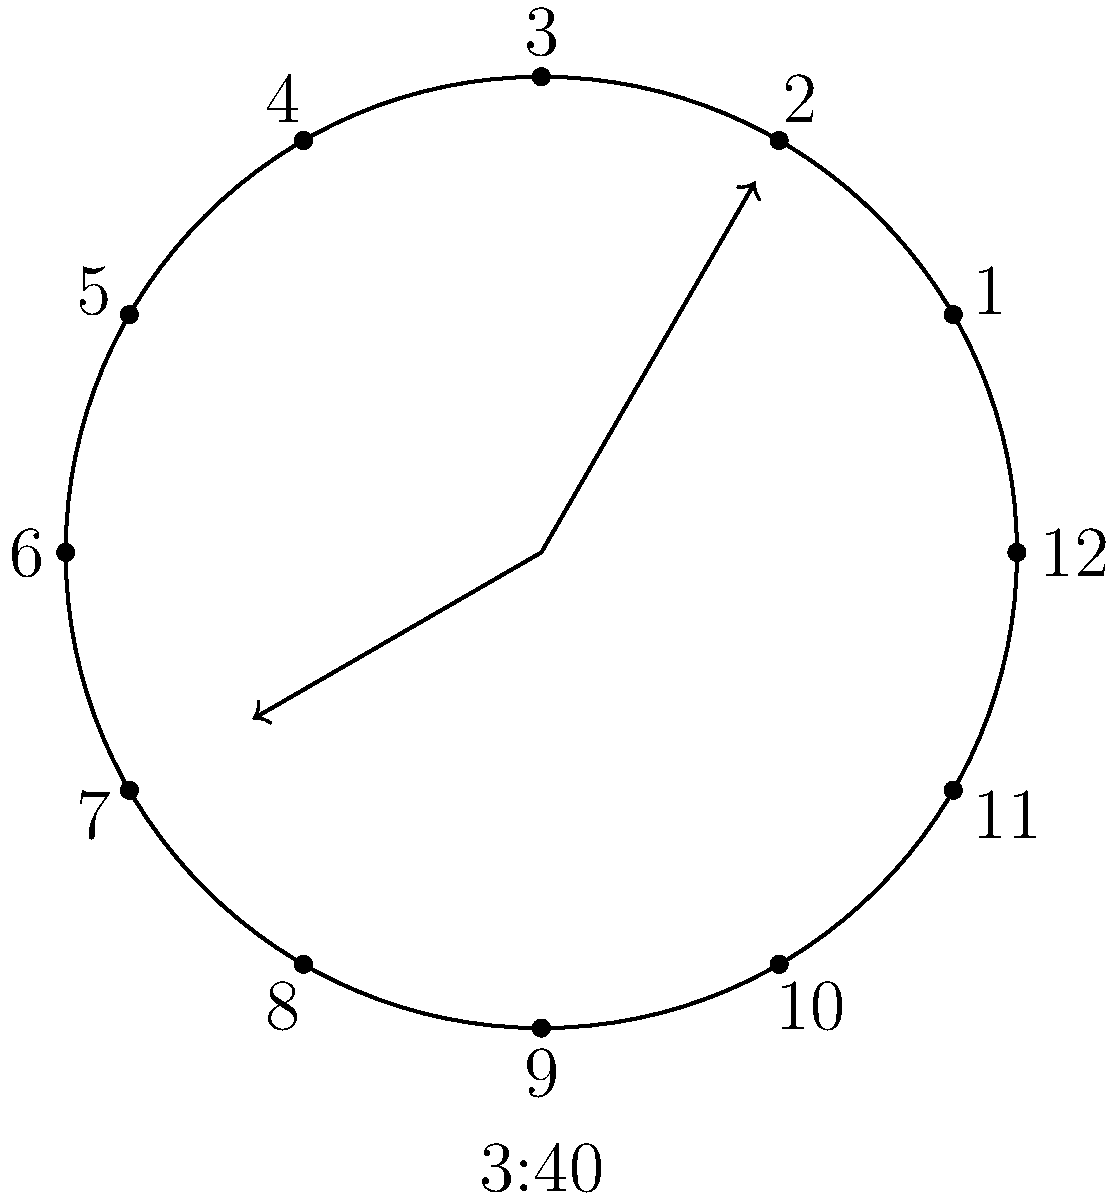As you're teaching your child to read an analog clock, you point out that at 3:40, the hour hand has moved slightly past 3. If we consider the angle formed between the hour and minute hands at this time, what is the measure of this angle to the nearest degree? Let's approach this step-by-step:

1) First, we need to calculate the angle of each hand:

   For the hour hand:
   - In 12 hours, it rotates 360°
   - In 1 hour, it rotates 360° ÷ 12 = 30°
   - In 40 minutes, it rotates an additional 40/60 * 30° = 20°
   - So at 3:40, the hour hand is at 3 * 30° + 20° = 110°

   For the minute hand:
   - In 60 minutes, it rotates 360°
   - In 40 minutes, it rotates 40 * 6° = 240°

2) The angle between the hands is the absolute difference between these angles:
   
   $|240° - 110°| = 130°$

3) However, we always want the smaller angle. If this angle is greater than 180°, we subtract it from 360°:

   $360° - 130° = 230°$

4) Since 130° is less than 180°, we keep this value.

Therefore, the angle between the hour and minute hands at 3:40 is 130°.
Answer: 130° 